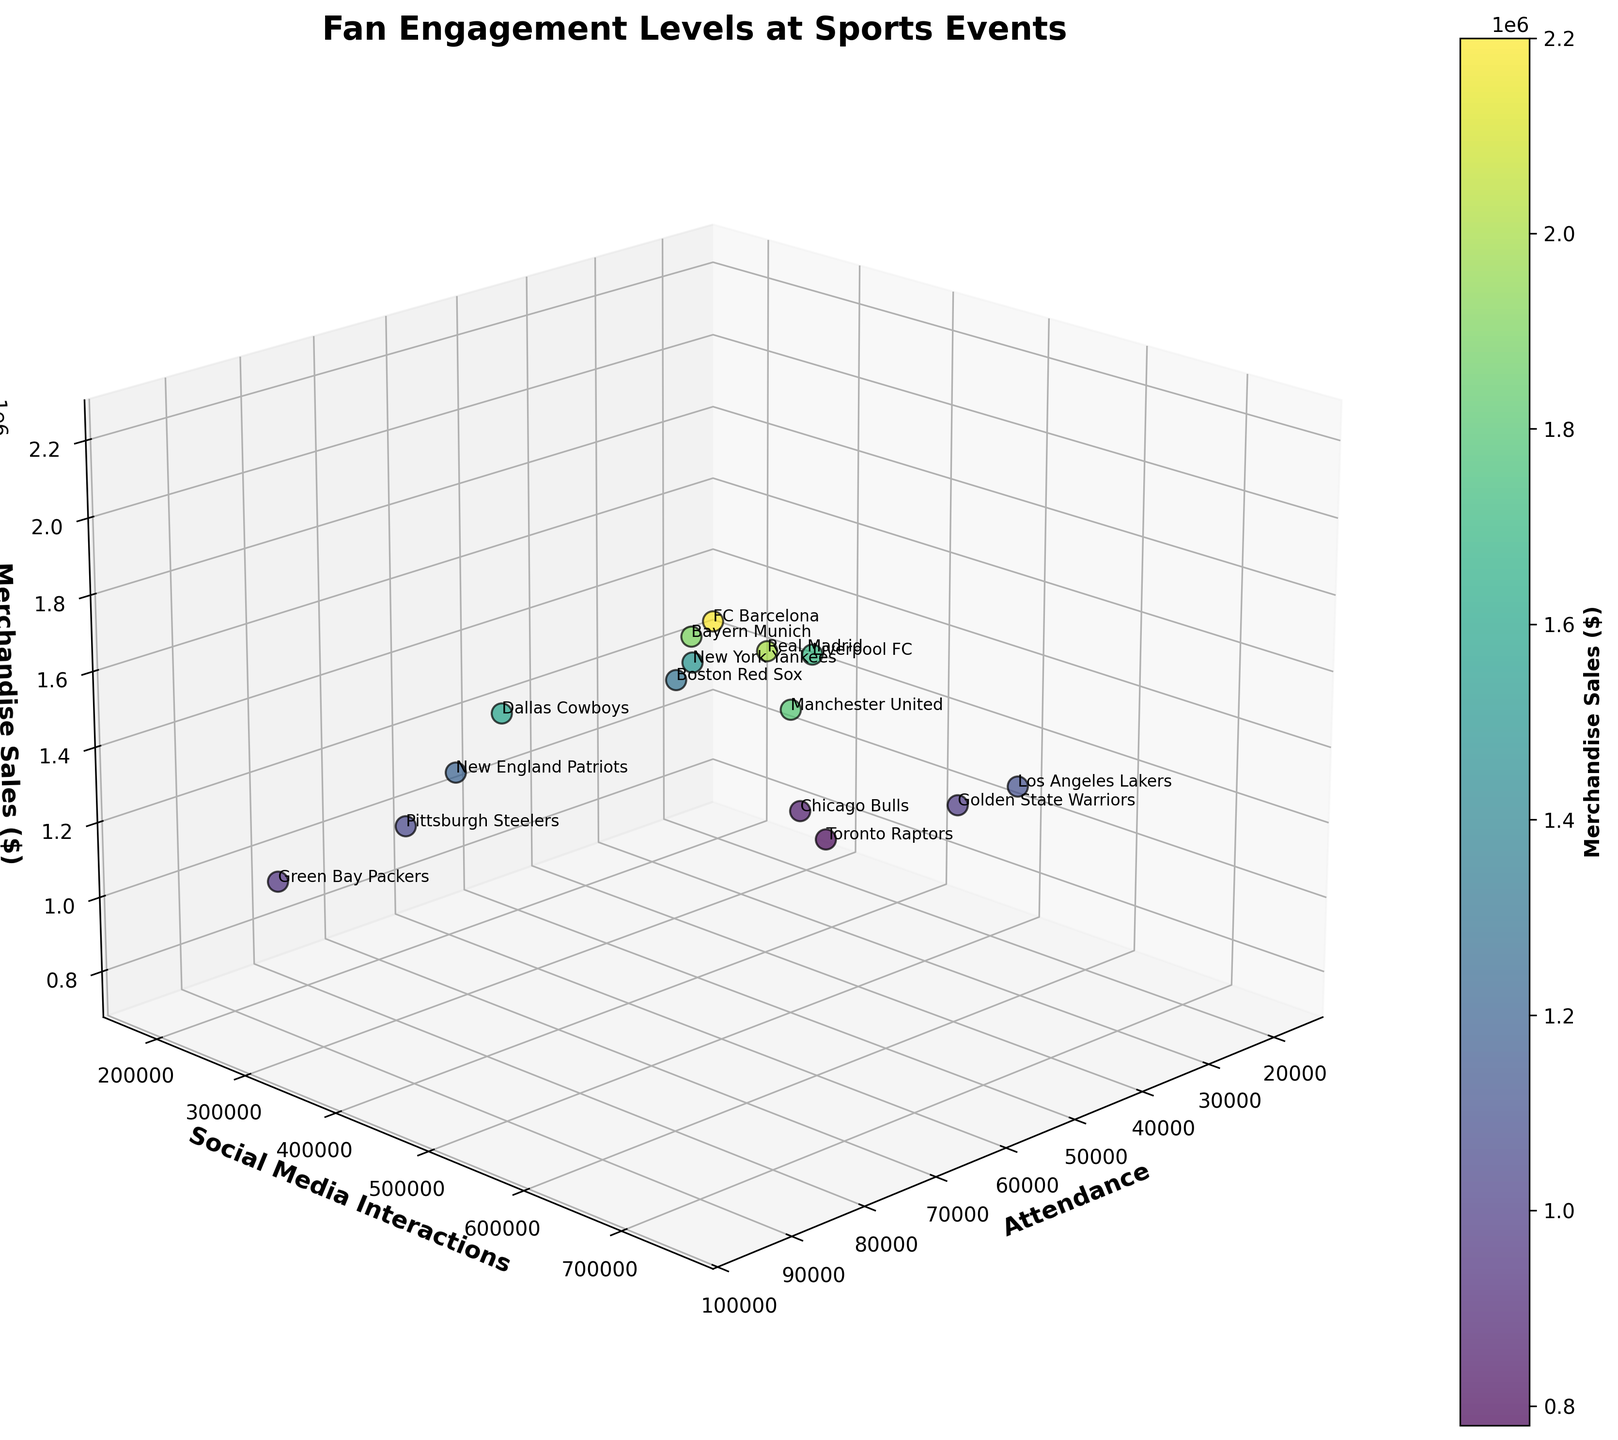what is the title of the plot? The title of the plot is located at the top of the figure. It summarizes the main topic of the visualization, making it easier to understand the context.
Answer: Fan Engagement Levels at Sports Events Which team has the highest attendance? The Attendance axis presents the highest values at the right end. Check which team label is at the highest value.
Answer: FC Barcelona How many teams have more than 700,000 social media interactions? Look along the Social Media Interactions axis for values greater than 700,000 and count the corresponding labels.
Answer: 3 teams Which team has the lowest merchandise sales? The Merchandise Sales axis presents the lowest values at the bottom. Check which team label is at the lowest value.
Answer: Toronto Raptors Which team has the highest merchandise sales? The Merchandise Sales axis presents the highest values at the top. Check which team label is at the highest value.
Answer: FC Barcelona Which teams have both high attendance (over 75,000) and high merchandise sales (over 1,800,000)? Identify the teams with Attendance values over 75,000 and Merchandise Sales over 1,800,000 by cross-referencing their labels within these ranges.
Answer: FC Barcelona, Manchester United, Real Madrid, Bayern Munich What's the relationship between attendance and social media interactions for the Boston Red Sox? Locate the Boston Red Sox label, observe its position along the Attendance and Social Media Interactions axes, and describe the relationship.
Answer: Moderate attendance, moderate social media interactions Among the teams with over 50,000 attendance, which team has the least social media interactions? Filter teams with Attendance over 50,000 and then compare their positions along the Social Media Interactions axis to find the lowest.
Answer: Green Bay Packers Which team shows high social media interactions but relatively low attendance? Identify teams with high values on the Social Media Interactions axis and low values on the Attendance axis by comparing their positions.
Answer: Golden State Warriors What is the average merchandise sales value of the listed teams? Sum all the Merchandise Sales values from the data provided and divide the total by the number of teams (15). This involves calculating (1200000 + 980000 + 1500000 + 2200000 + 850000 + 1100000 + 1800000 + 1600000 + 2000000 + 950000 + 1300000 + 1700000 + 780000 + 1050000 + 1900000) / 15.
Answer: 1368666.67 